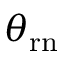<formula> <loc_0><loc_0><loc_500><loc_500>\theta _ { { r } n }</formula> 